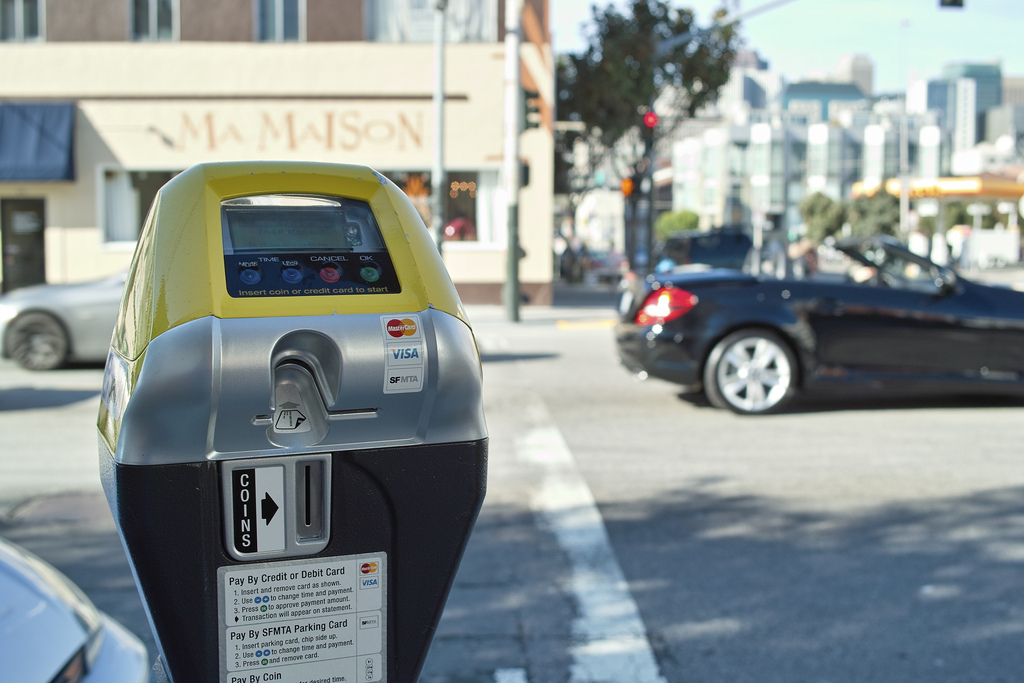What is the color of the vehicle the meter is to the left of? The vehicle to the left of the meter is black. 